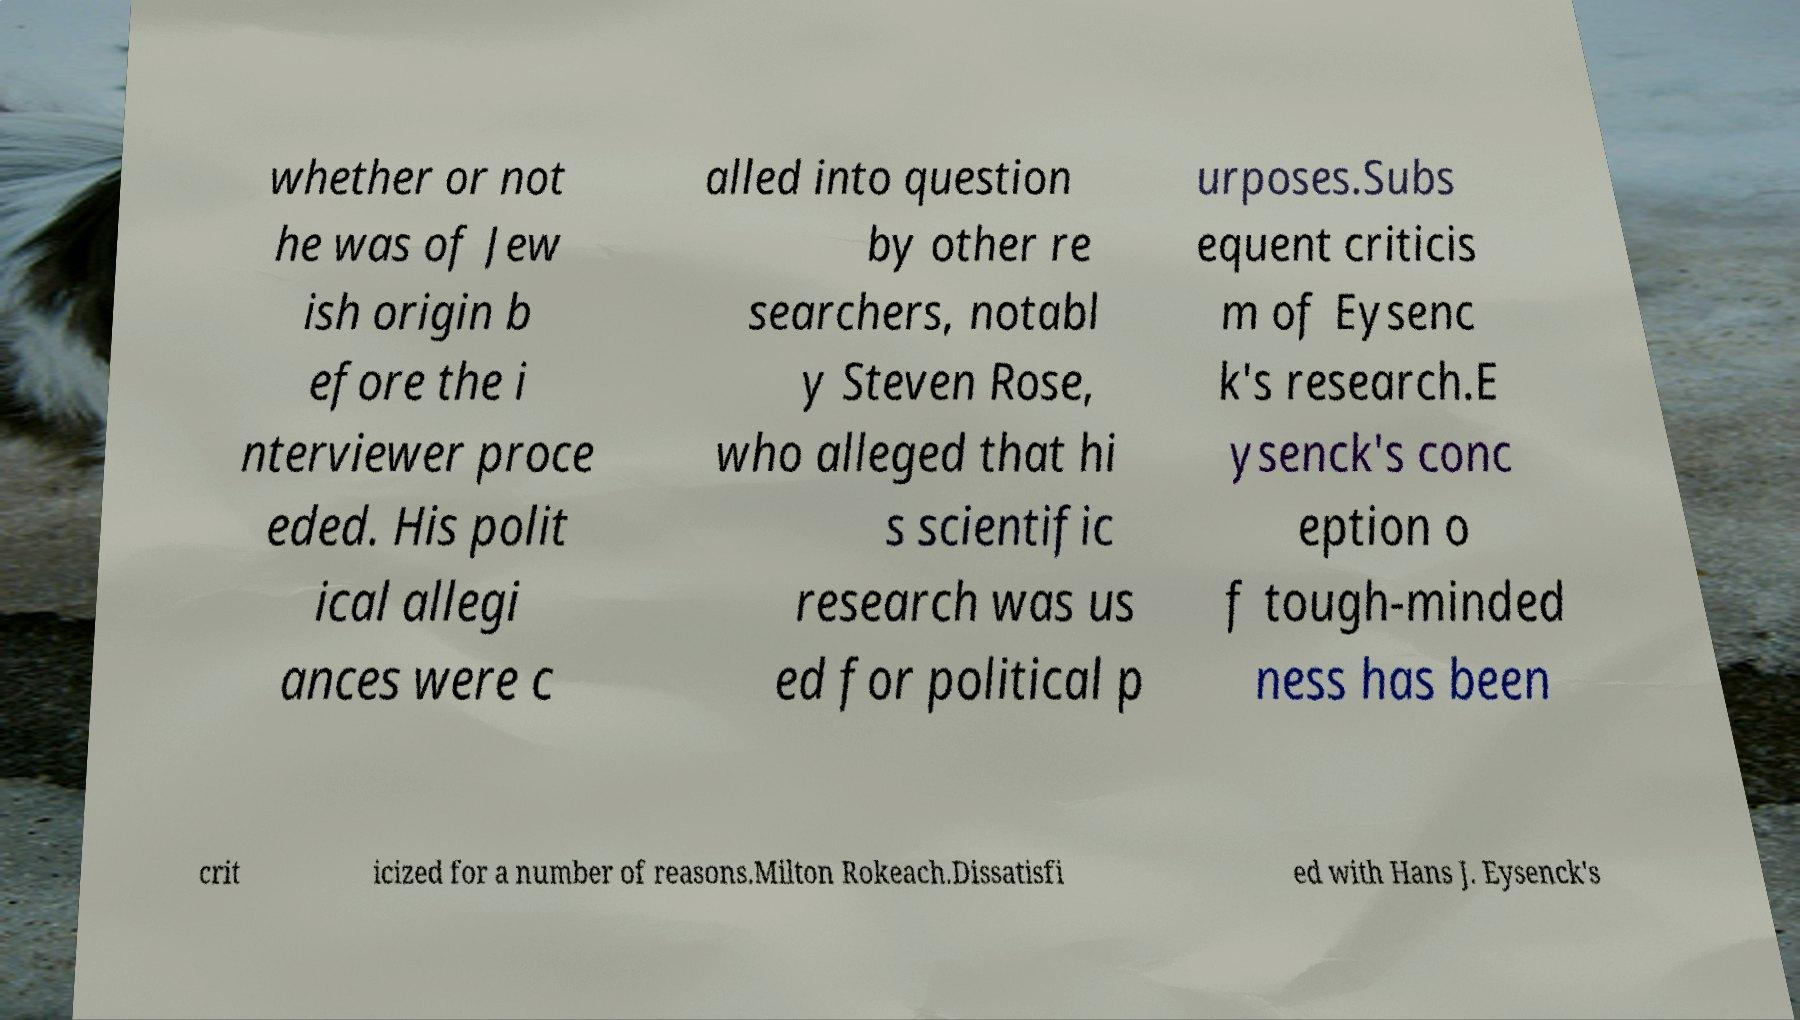Please read and relay the text visible in this image. What does it say? whether or not he was of Jew ish origin b efore the i nterviewer proce eded. His polit ical allegi ances were c alled into question by other re searchers, notabl y Steven Rose, who alleged that hi s scientific research was us ed for political p urposes.Subs equent criticis m of Eysenc k's research.E ysenck's conc eption o f tough-minded ness has been crit icized for a number of reasons.Milton Rokeach.Dissatisfi ed with Hans J. Eysenck's 